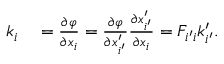Convert formula to latex. <formula><loc_0><loc_0><loc_500><loc_500>\begin{array} { r l } { k _ { i } } & = \frac { \partial \varphi } { \partial x _ { i } } = \frac { \partial \varphi } { \partial x _ { i ^ { \prime } } ^ { \prime } } \frac { \partial x _ { i ^ { \prime } } ^ { \prime } } { \partial x _ { i } } = F _ { i ^ { \prime } i } k _ { i ^ { \prime } } ^ { \prime } . } \end{array}</formula> 